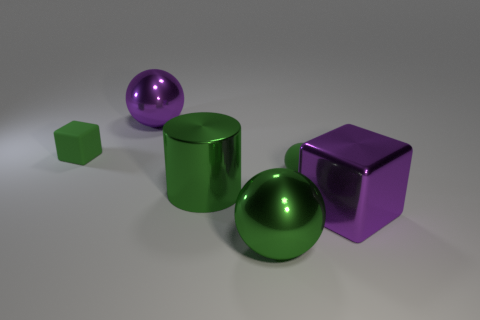What might be the purpose of this arrangement? The arrangement of these objects seems to be a deliberate composition likely designed for a visual study, showcasing the interplay of light and reflections on various geometric shapes and materials that possess different colors. 